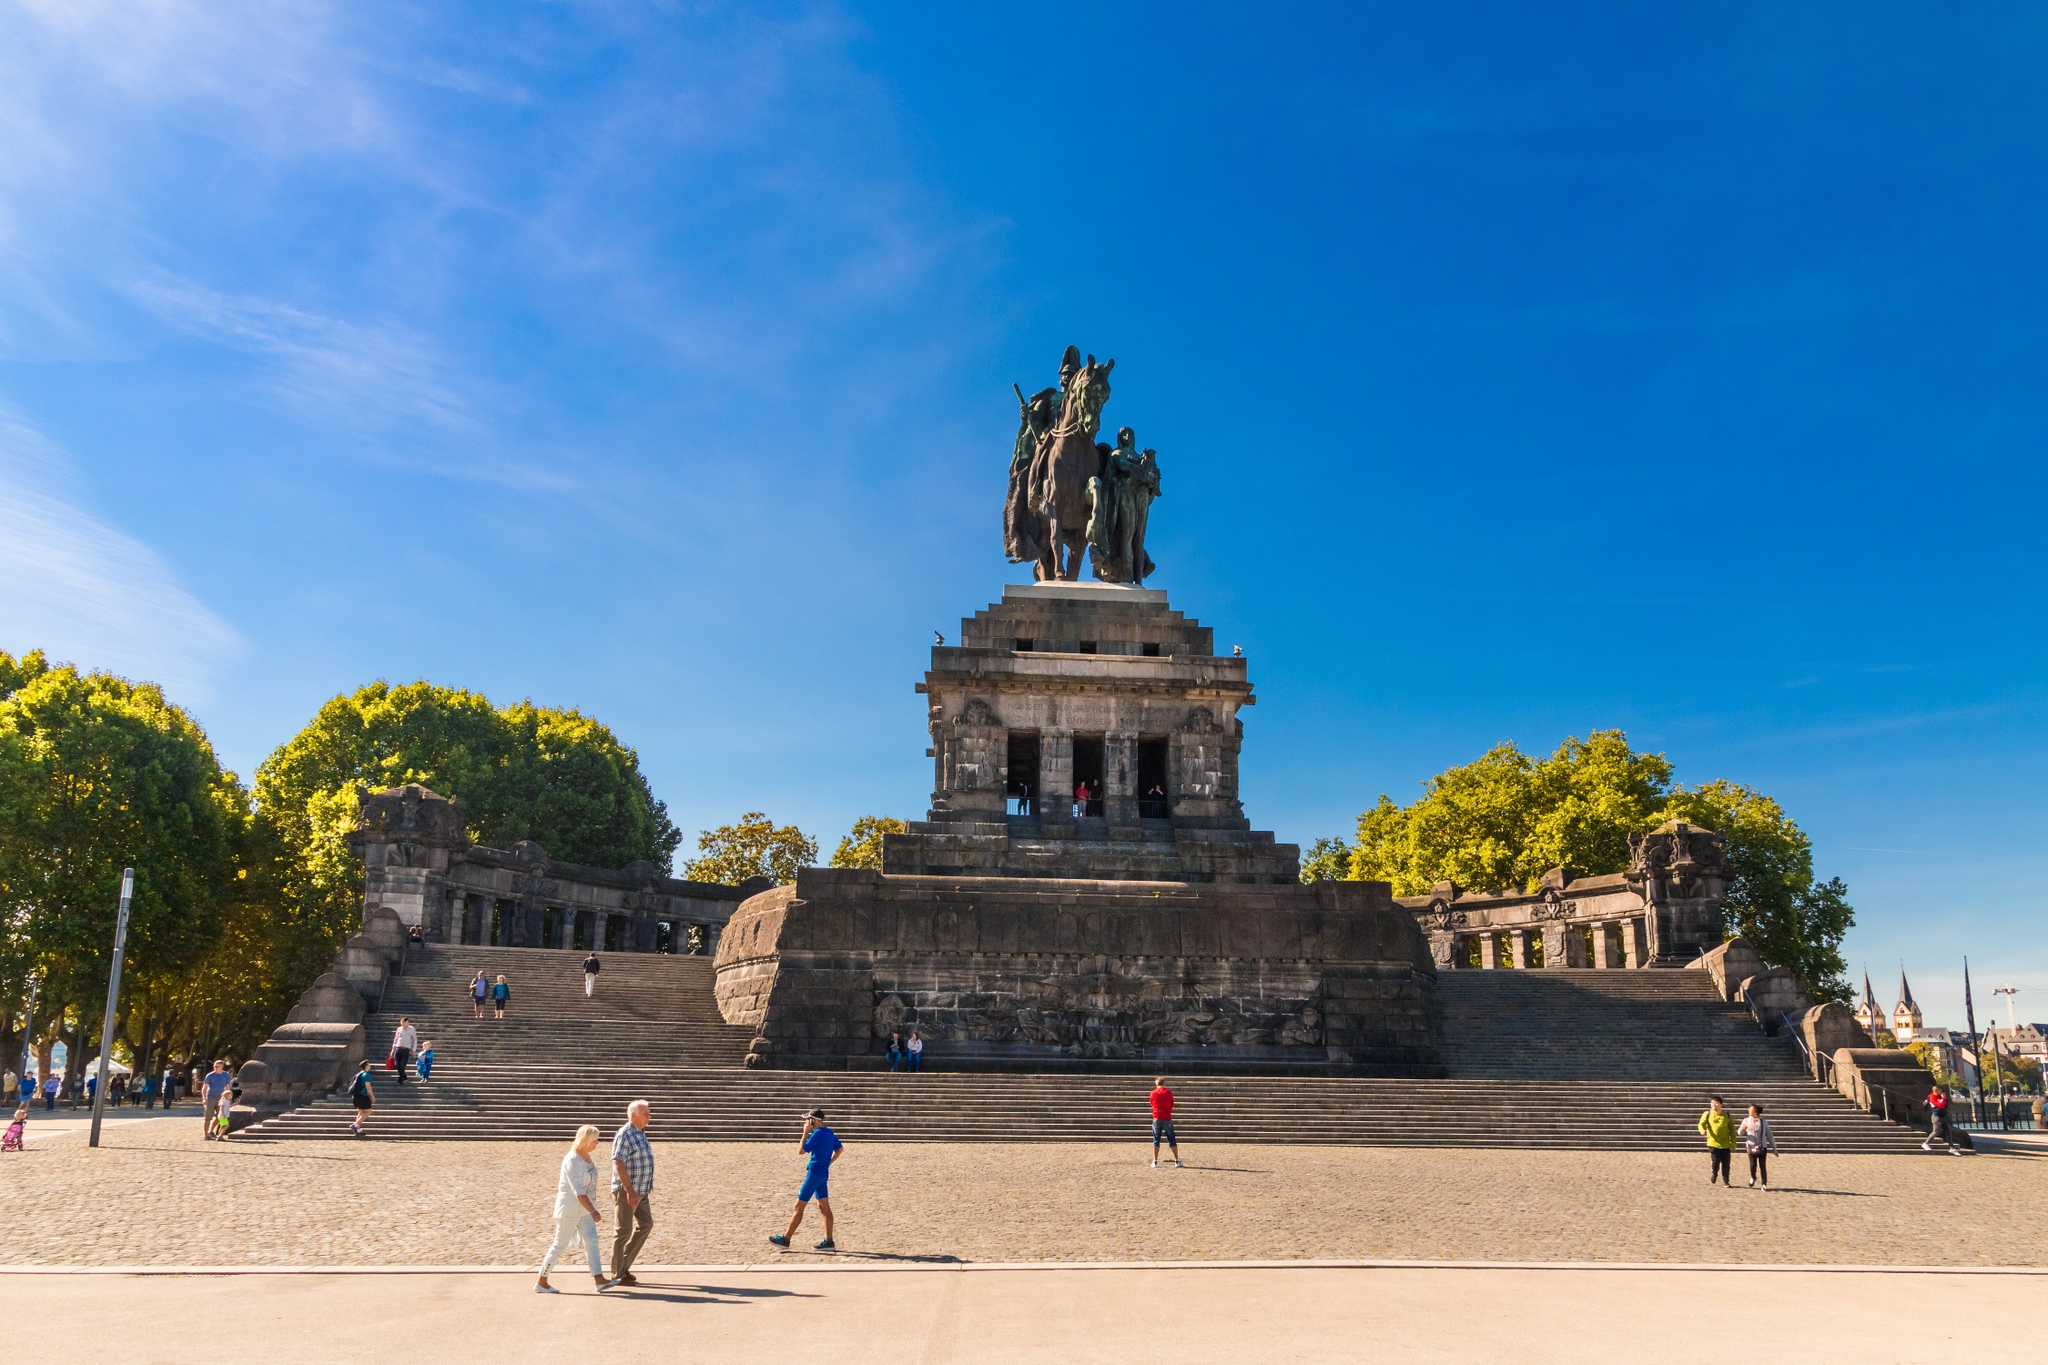Imagine if the statue came to life at night. What adventures would it embark on? If the statue of William I came to life at night, it would embark on grand adventures, galloping through the cobbled streets of Koblenz under the cloak of darkness, its bronze hooves echoing in the night. The Emperor might visit other monuments and historical sites, sharing stories with statues of great leaders, forming an unseen council of the ages. As dawn breaks, it would return to its pedestal, resuming its stoic vigil, leaving behind only whispers and legends for those who might believe. 